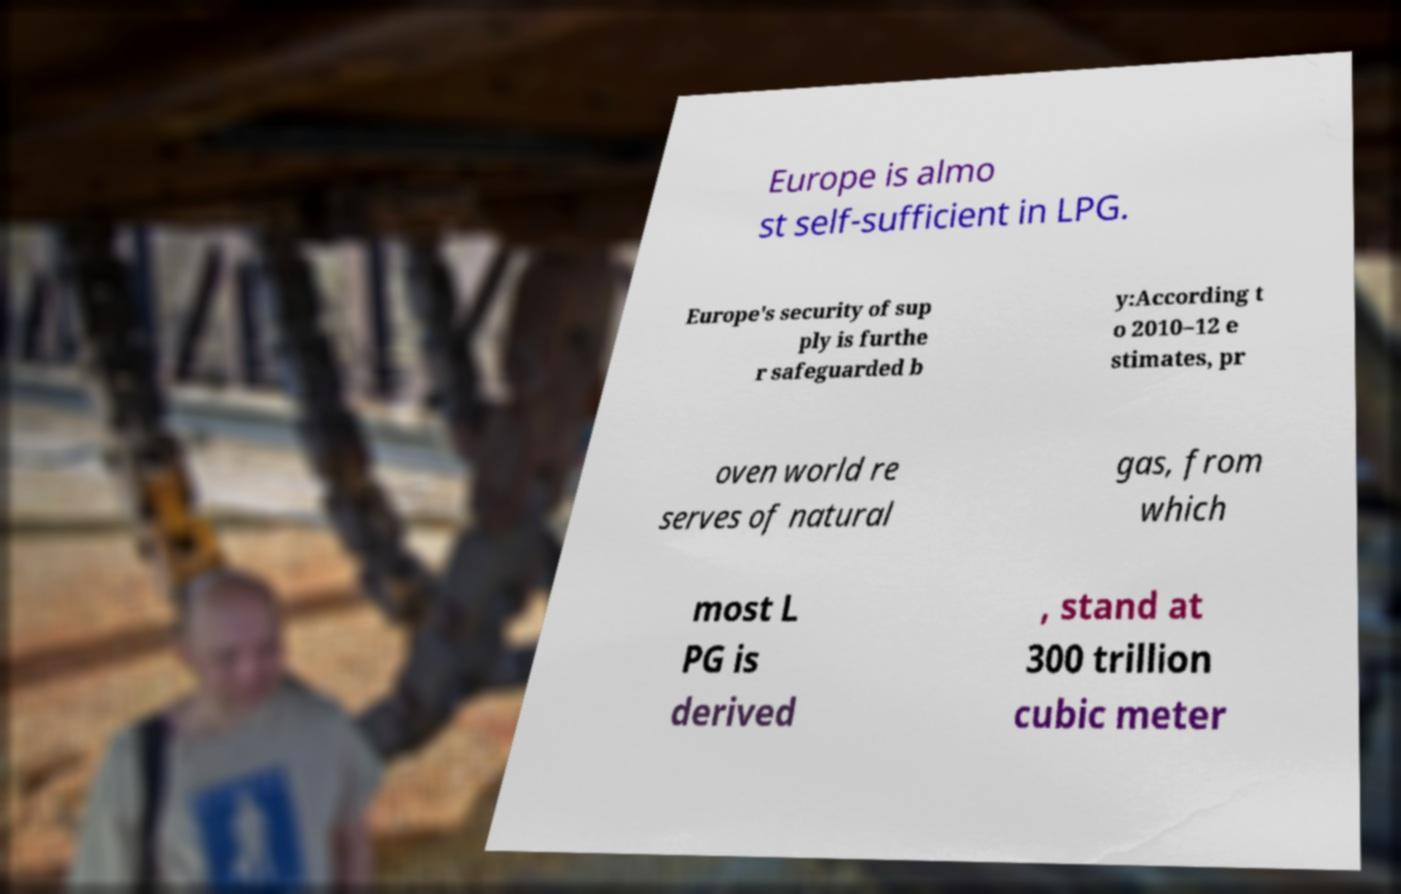Could you assist in decoding the text presented in this image and type it out clearly? Europe is almo st self-sufficient in LPG. Europe's security of sup ply is furthe r safeguarded b y:According t o 2010–12 e stimates, pr oven world re serves of natural gas, from which most L PG is derived , stand at 300 trillion cubic meter 